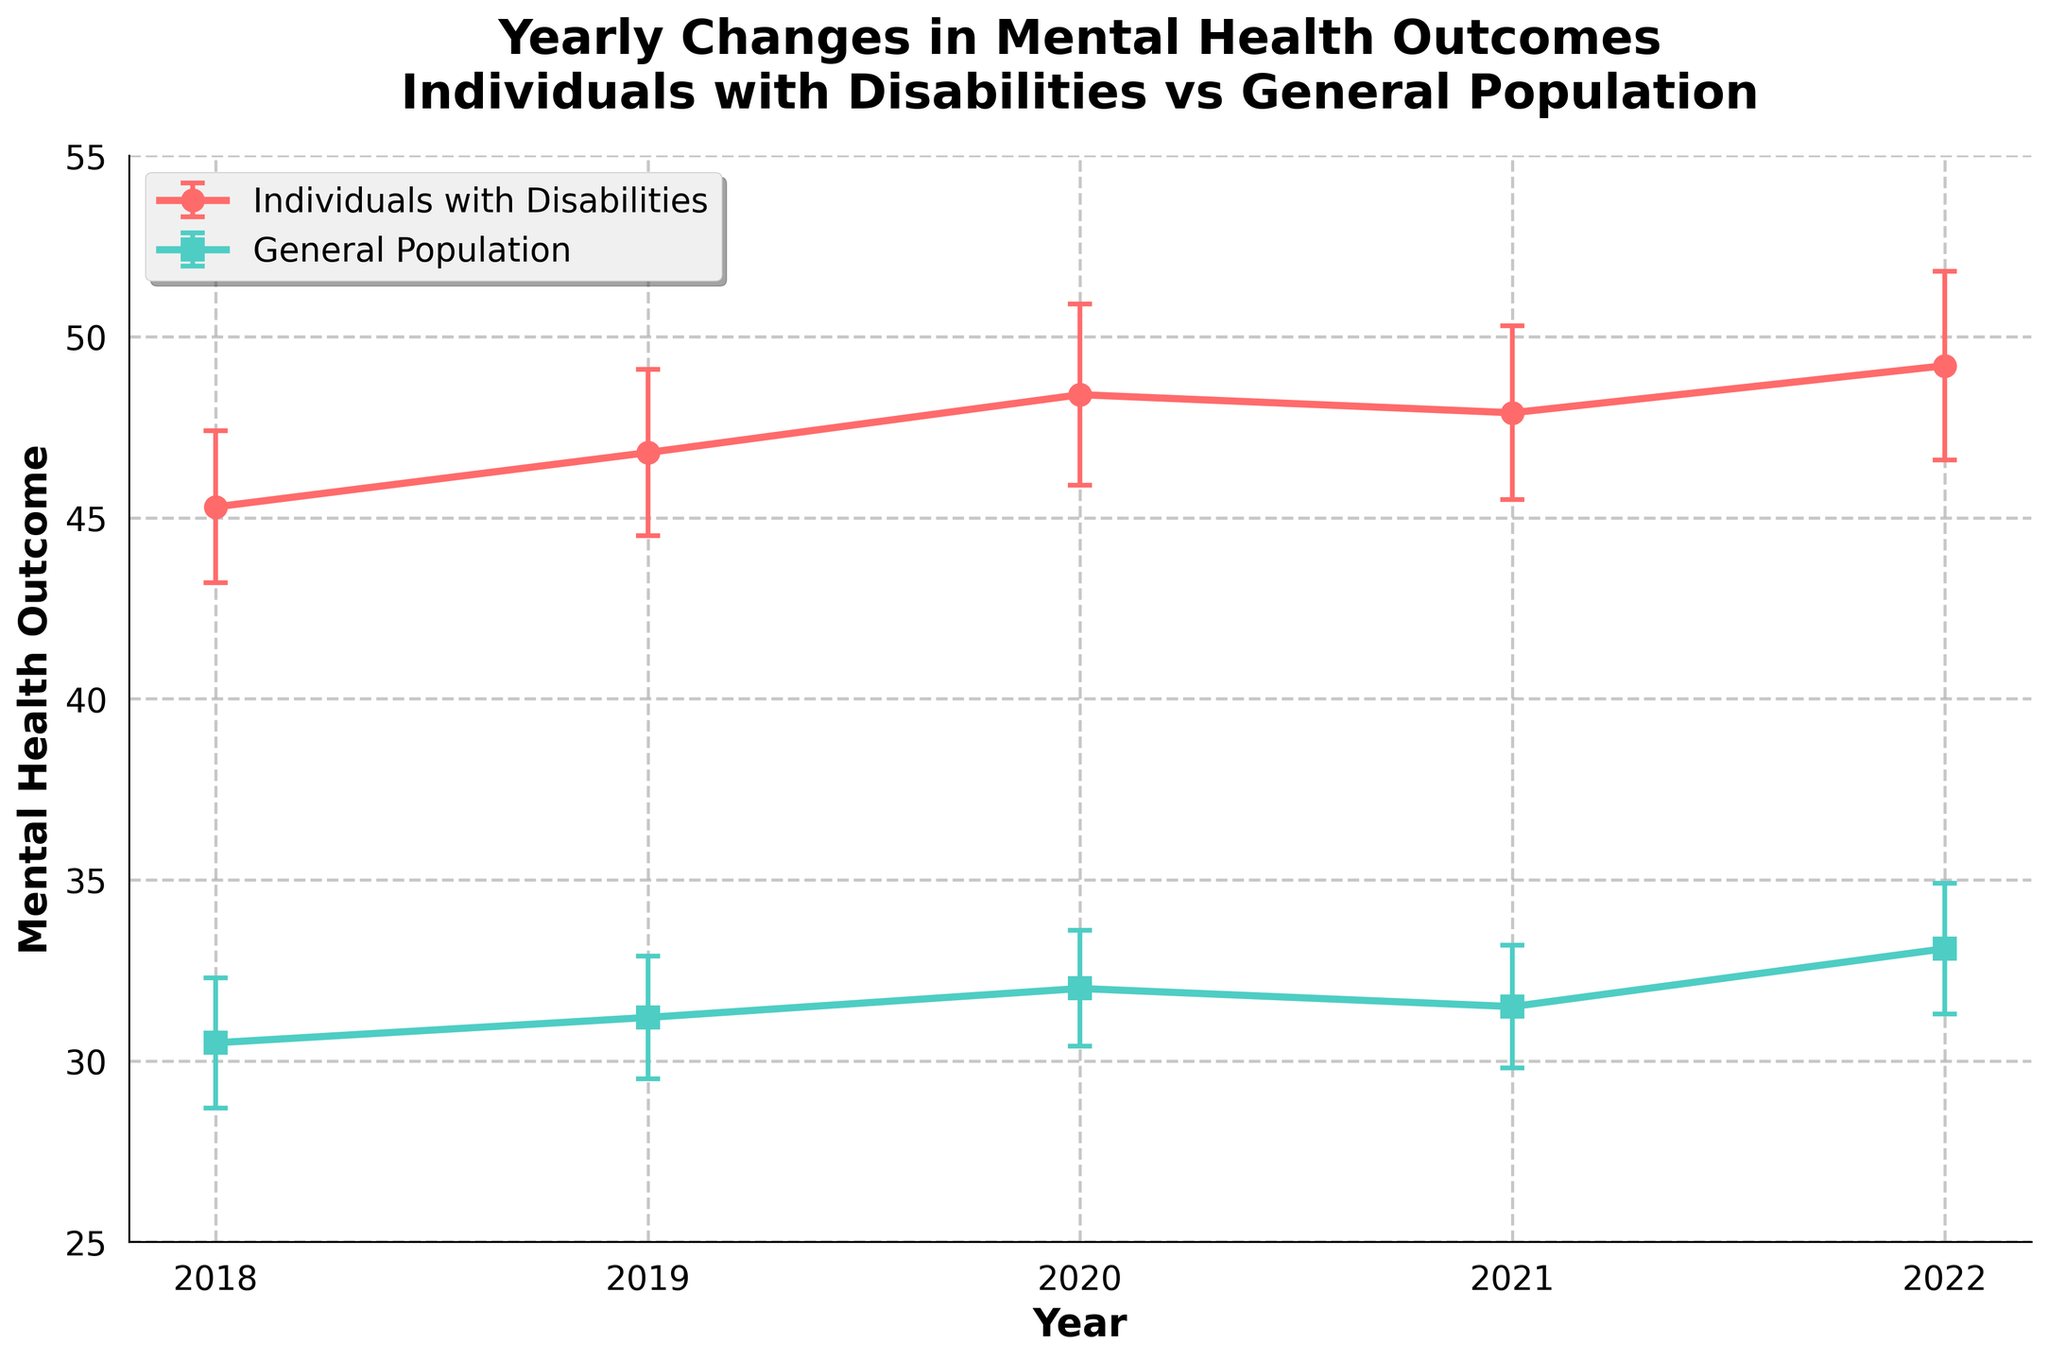What is the title of the plot? The title of the plot is typically displayed at the top in a bold, larger font. Reading from the title area, it states: "Yearly Changes in Mental Health Outcomes Individuals with Disabilities vs General Population."
Answer: Yearly Changes in Mental Health Outcomes Individuals with Disabilities vs General Population How many data points are there for each group? By counting the markers shown in the plot for each group, we see 5 markers for 'Individuals with Disabilities' and 5 markers for 'General Population,' indicating there are 5 data points for each group.
Answer: 5 What was the mental health outcome for the general population in 2020? Locate the year 2020 on the x-axis, then check the y-value for the 'General Population.' This value is close to 32.0, as labeled.
Answer: 32.0 Which group had the highest mental health outcome in 2022? For the year 2022, check the y-values for both groups. 'Individuals with Disabilities' show approximately 49.2, while the 'General Population' shows around 33.1. The higher value is 49.2 from 'Individuals with Disabilities.'
Answer: Individuals with Disabilities How did the mental health outcomes for individuals with disabilities change from 2018 to 2022? Look at the points for 'Individuals with Disabilities' in 2018 and 2022. The y-value starts at around 45.3 in 2018 and increases to around 49.2 in 2022. This indicates an increase in the mental health outcome.
Answer: Increased What is the difference in mental health outcome between the two groups in 2021? For the year 2021, find the y-values for both groups. 'Individuals with Disabilities' is approximately 47.9, and 'General Population' is around 31.5. The difference is 47.9 - 31.5 = 16.4.
Answer: 16.4 Which group shows more variability in the mental health outcomes over the years? Variability can be assessed by looking at the confidence intervals (error bars). The width of the error bars for 'Individuals with Disabilities' is consistently larger than for the 'General Population,' indicating more variability.
Answer: Individuals with Disabilities What can you infer about the trend in mental health outcomes for the general population from 2018 to 2022? Examine the y-values for the 'General Population' from 2018 to 2022. The values are 30.5, 31.2, 32.0, 31.5, and 33.1, which show a slight overall increase over the years.
Answer: Slightly increased How did the mental health outcome for individuals with disabilities change from 2020 to 2021? Look at the points for 'Individuals with Disabilities' in 2020 and 2021. The y-value changes from around 48.4 in 2020 to around 47.9 in 2021, indicating a slight decrease.
Answer: Decreased 